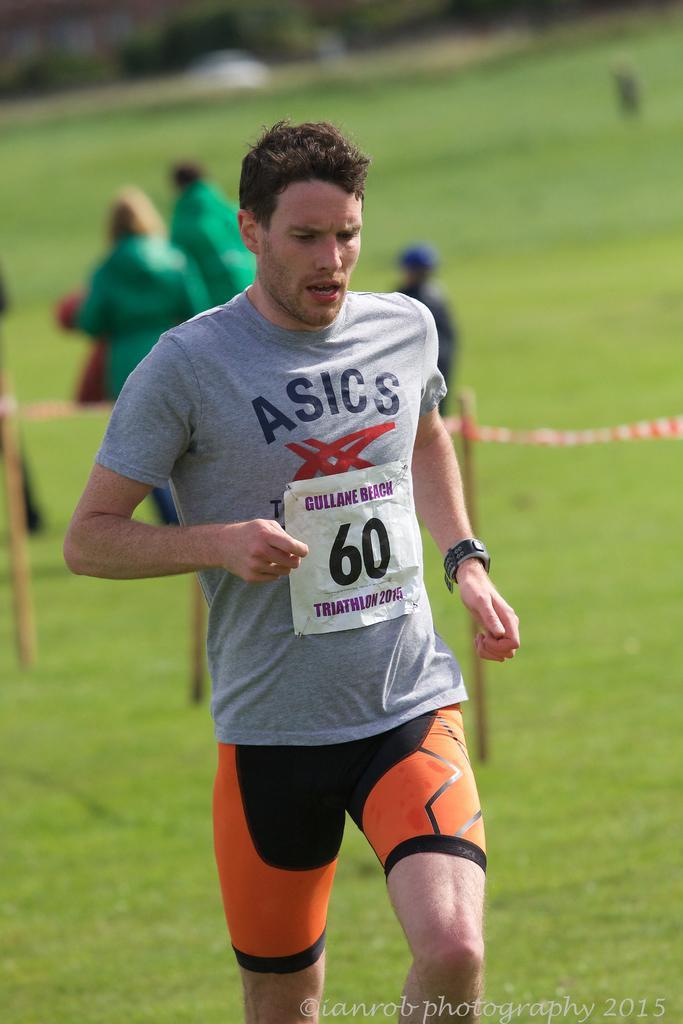Describe this image in one or two sentences. In this image we can see a few people, one of them is running, there is a thread tied to the poles, and the background is blurred. 